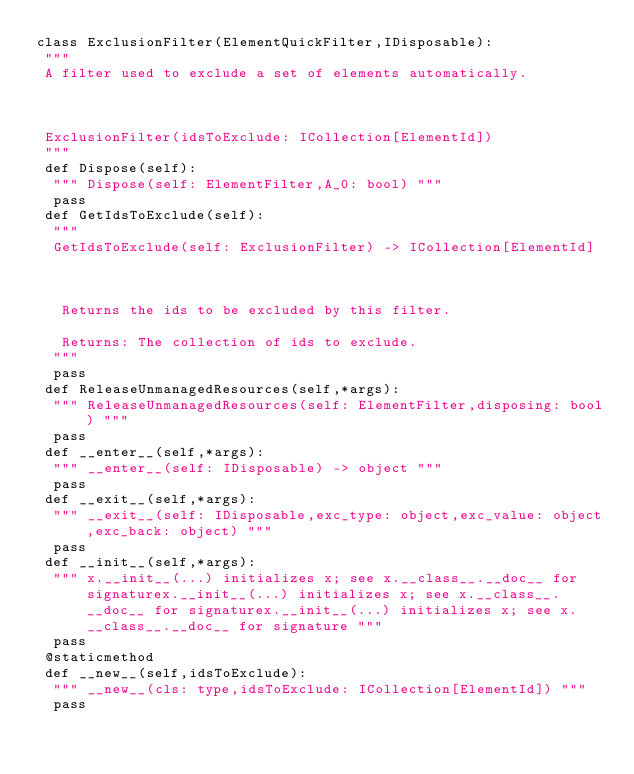Convert code to text. <code><loc_0><loc_0><loc_500><loc_500><_Python_>class ExclusionFilter(ElementQuickFilter,IDisposable):
 """
 A filter used to exclude a set of elements automatically.
 
 ExclusionFilter(idsToExclude: ICollection[ElementId])
 """
 def Dispose(self):
  """ Dispose(self: ElementFilter,A_0: bool) """
  pass
 def GetIdsToExclude(self):
  """
  GetIdsToExclude(self: ExclusionFilter) -> ICollection[ElementId]
  
   Returns the ids to be excluded by this filter.
   Returns: The collection of ids to exclude.
  """
  pass
 def ReleaseUnmanagedResources(self,*args):
  """ ReleaseUnmanagedResources(self: ElementFilter,disposing: bool) """
  pass
 def __enter__(self,*args):
  """ __enter__(self: IDisposable) -> object """
  pass
 def __exit__(self,*args):
  """ __exit__(self: IDisposable,exc_type: object,exc_value: object,exc_back: object) """
  pass
 def __init__(self,*args):
  """ x.__init__(...) initializes x; see x.__class__.__doc__ for signaturex.__init__(...) initializes x; see x.__class__.__doc__ for signaturex.__init__(...) initializes x; see x.__class__.__doc__ for signature """
  pass
 @staticmethod
 def __new__(self,idsToExclude):
  """ __new__(cls: type,idsToExclude: ICollection[ElementId]) """
  pass
</code> 